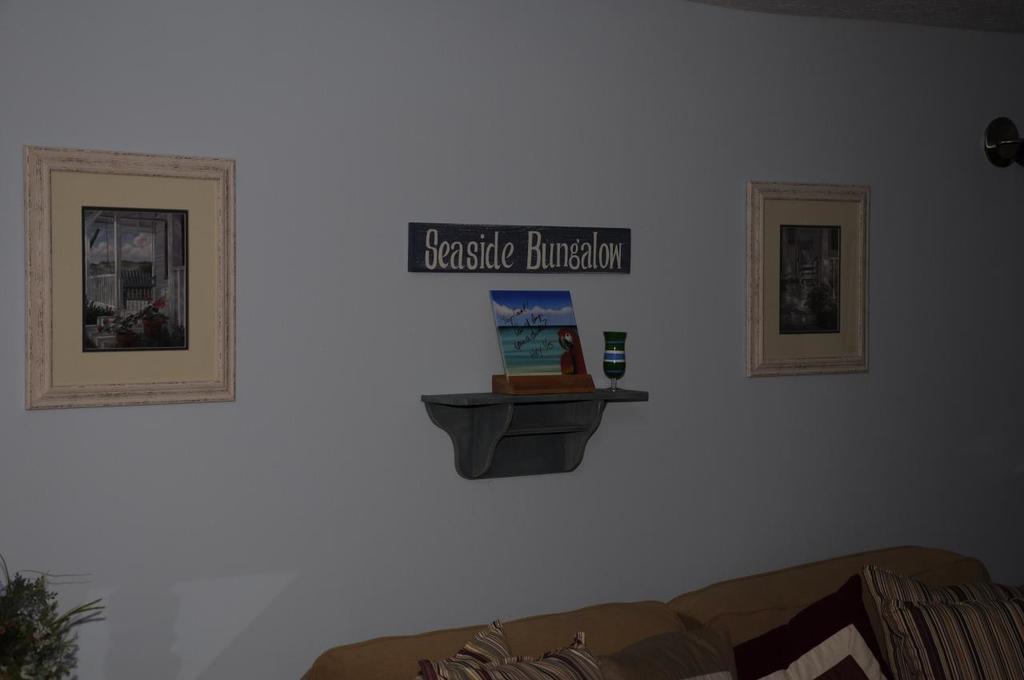Describe this image in one or two sentences. In this image at the bottom there is a couch and pillows, and plant and there are some photo frames on the wall. And in the center there is a name board, on the board there is text and there is one book and some object on the board. 